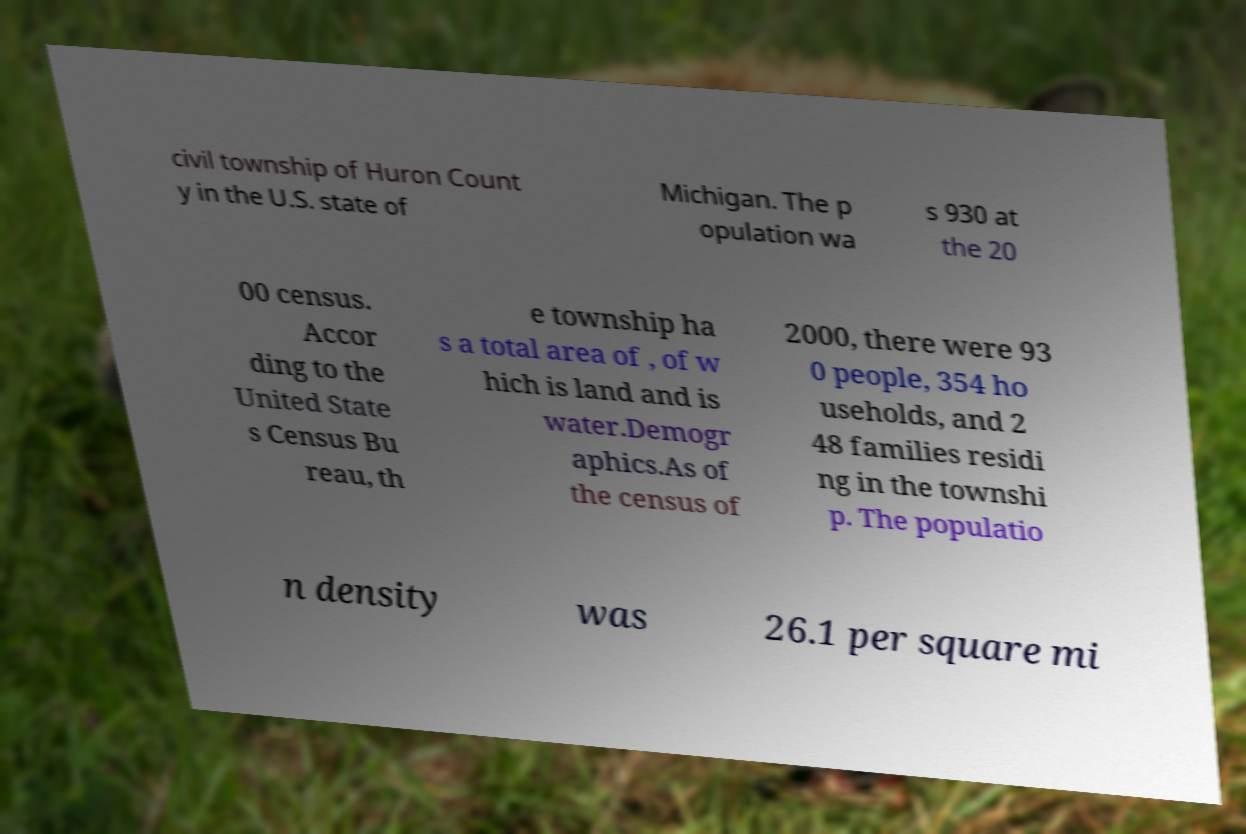Could you extract and type out the text from this image? civil township of Huron Count y in the U.S. state of Michigan. The p opulation wa s 930 at the 20 00 census. Accor ding to the United State s Census Bu reau, th e township ha s a total area of , of w hich is land and is water.Demogr aphics.As of the census of 2000, there were 93 0 people, 354 ho useholds, and 2 48 families residi ng in the townshi p. The populatio n density was 26.1 per square mi 